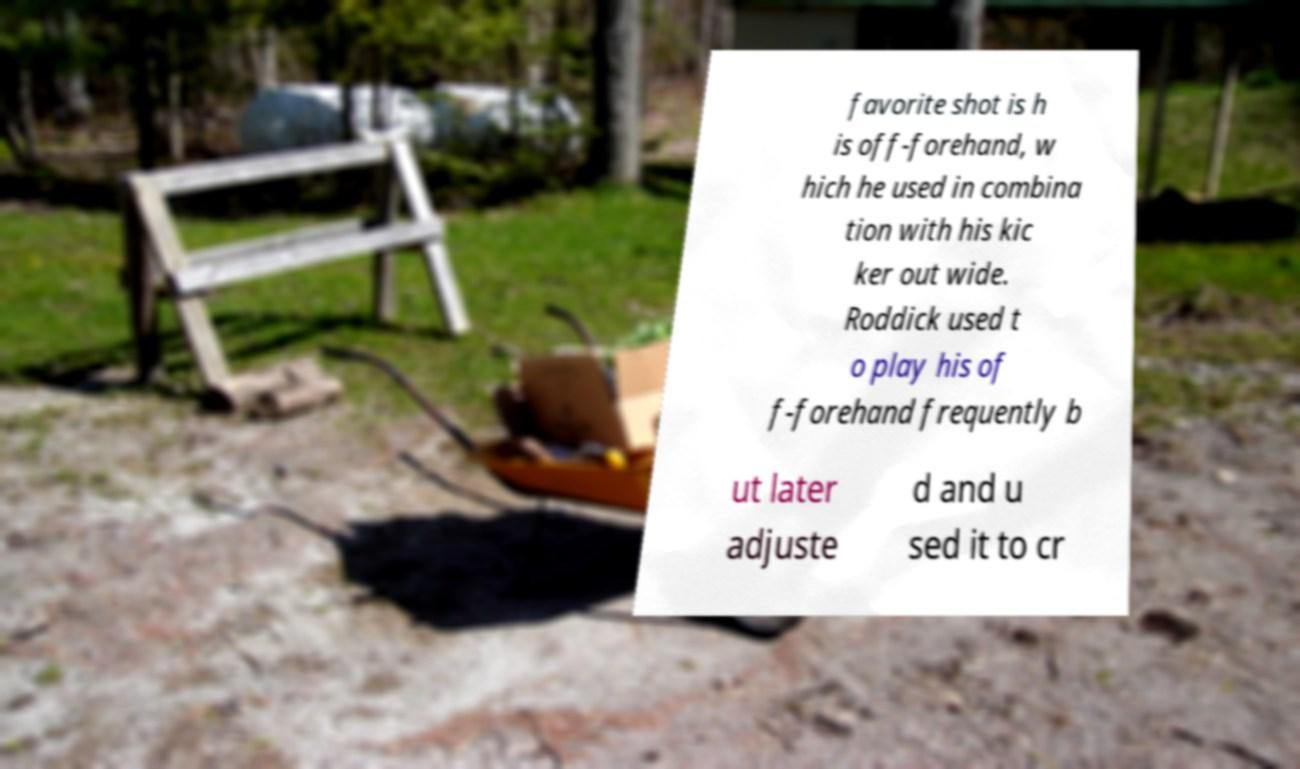Could you extract and type out the text from this image? favorite shot is h is off-forehand, w hich he used in combina tion with his kic ker out wide. Roddick used t o play his of f-forehand frequently b ut later adjuste d and u sed it to cr 